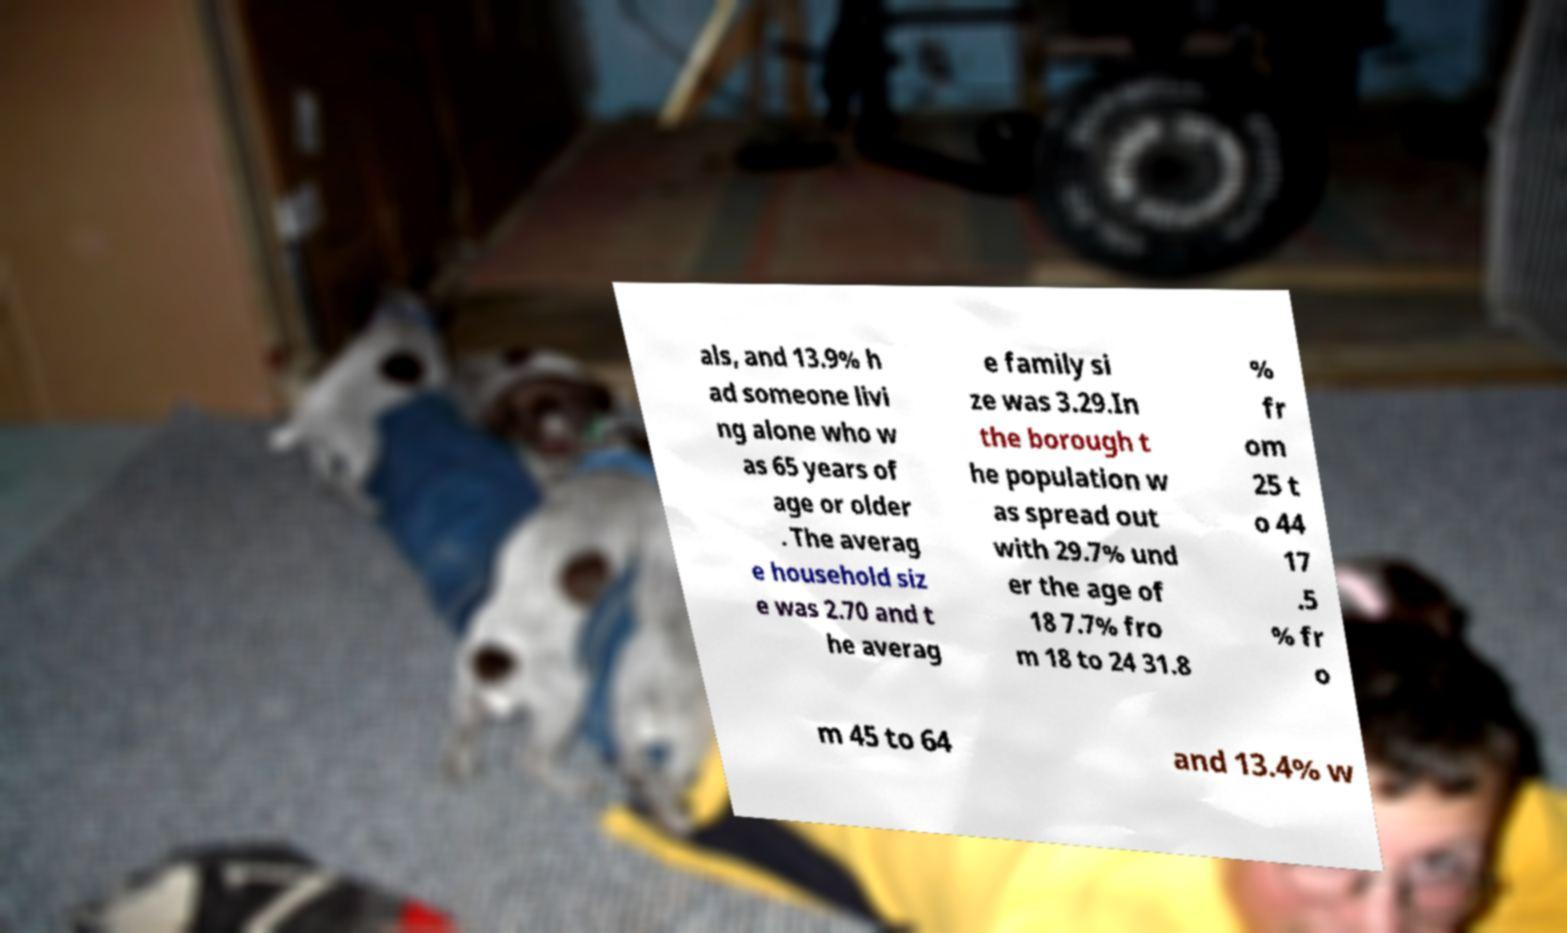Please identify and transcribe the text found in this image. als, and 13.9% h ad someone livi ng alone who w as 65 years of age or older . The averag e household siz e was 2.70 and t he averag e family si ze was 3.29.In the borough t he population w as spread out with 29.7% und er the age of 18 7.7% fro m 18 to 24 31.8 % fr om 25 t o 44 17 .5 % fr o m 45 to 64 and 13.4% w 